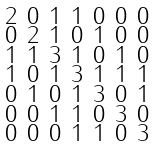<formula> <loc_0><loc_0><loc_500><loc_500>\begin{smallmatrix} 2 & 0 & 1 & 1 & 0 & 0 & 0 \\ 0 & 2 & 1 & 0 & 1 & 0 & 0 \\ 1 & 1 & 3 & 1 & 0 & 1 & 0 \\ 1 & 0 & 1 & 3 & 1 & 1 & 1 \\ 0 & 1 & 0 & 1 & 3 & 0 & 1 \\ 0 & 0 & 1 & 1 & 0 & 3 & 0 \\ 0 & 0 & 0 & 1 & 1 & 0 & 3 \end{smallmatrix}</formula> 